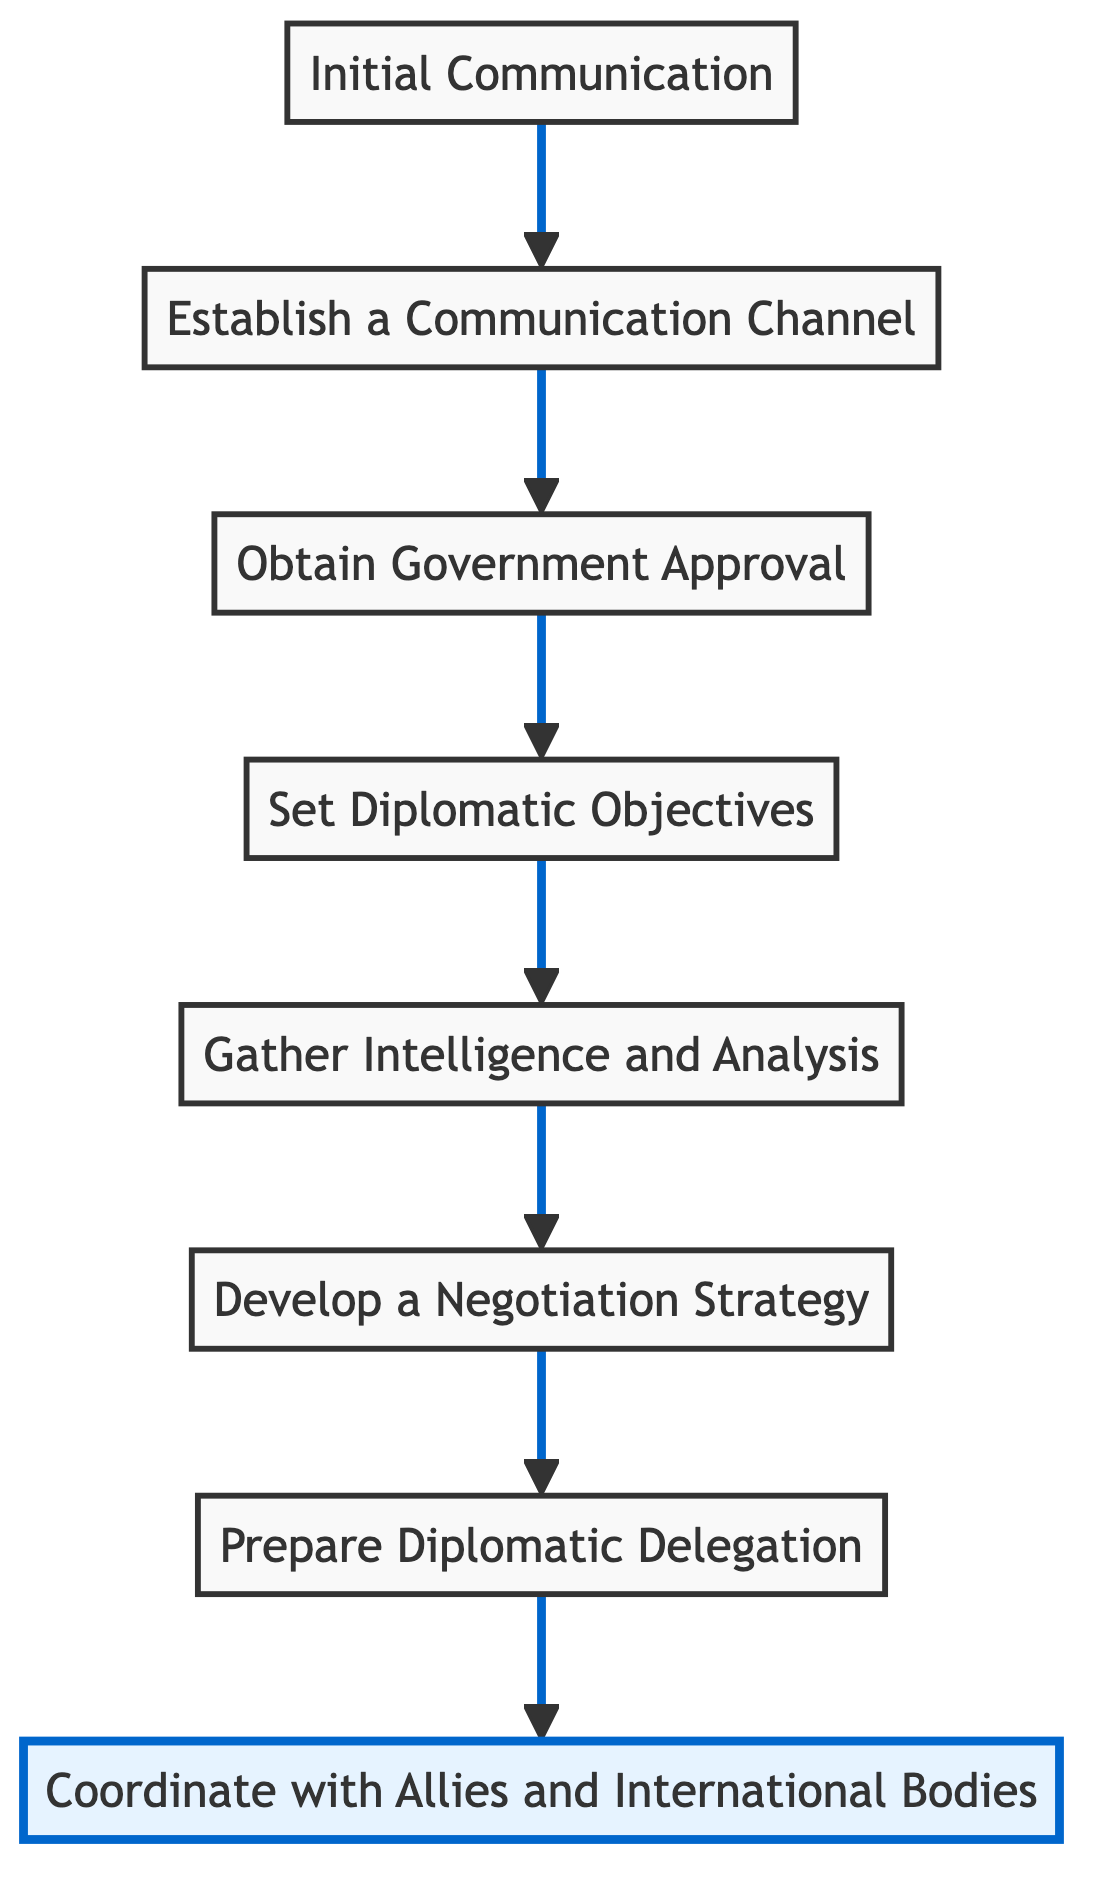What is the first step in the flowchart? The first step in the flowchart, moving from bottom to up, is "Initial Communication." It is clearly labeled as the starting point of the process.
Answer: Initial Communication How many steps are there in total? The flowchart contains eight distinct steps, which can be counted from "Initial Communication" to "Coordinate with Allies and International Bodies."
Answer: Eight What follows after "Set Diplomatic Objectives"? The next step after "Set Diplomatic Objectives" is "Gather Intelligence and Analysis," demonstrating the logical sequence of the process in the flowchart.
Answer: Gather Intelligence and Analysis What is the last step in the flowchart? The final step at the top of the flowchart is "Coordinate with Allies and International Bodies," indicating that this is the concluding part of the diplomatic engagement process.
Answer: Coordinate with Allies and International Bodies Which step requires approval from the government? The step titled "Obtain Government Approval" specifically indicates that this step entails seeking formal authorization from relevant government bodies.
Answer: Obtain Government Approval How does the step "Develop a Negotiation Strategy" relate to "Gather Intelligence and Analysis"? "Gather Intelligence and Analysis" provides essential information to inform "Develop a Negotiation Strategy," indicating that the latter step relies on the analysis from the former for effectiveness.
Answer: Develop a Negotiation Strategy What step comes immediately before preparing the diplomatic delegation? The step immediately before "Prepare Diplomatic Delegation" is "Develop a Negotiation Strategy," which suggests that the strategy lays the groundwork for forming the delegation.
Answer: Develop a Negotiation Strategy What is the purpose of establishing a communication channel? The purpose of "Establish a Communication Channel" is to ensure a dedicated and secure line for ongoing discussions, which is critical for effective diplomatic engagement.
Answer: Ensure effective communication What is the relationship between "Initial Communication" and "Establish a Communication Channel"? "Initial Communication" initiates the diplomatic talks, and following that, "Establish a Communication Channel" is necessary to facilitate further interactions; thus, the former leads into the latter.
Answer: Initial Communication leads to Establish a Communication Channel 